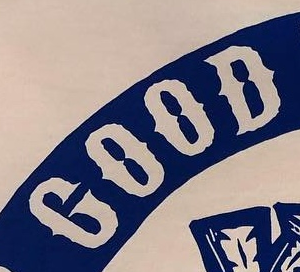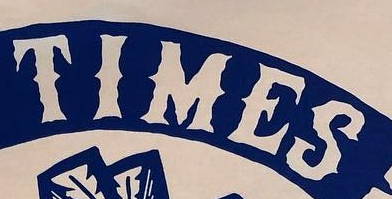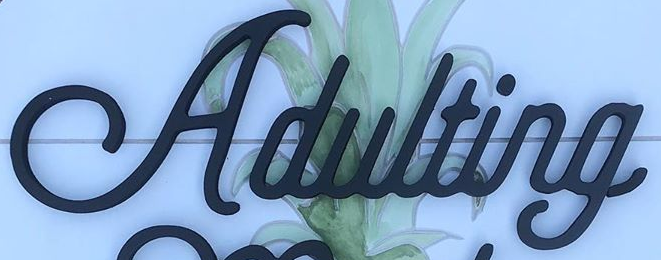What text appears in these images from left to right, separated by a semicolon? GOOD; TIMES; Adulting 